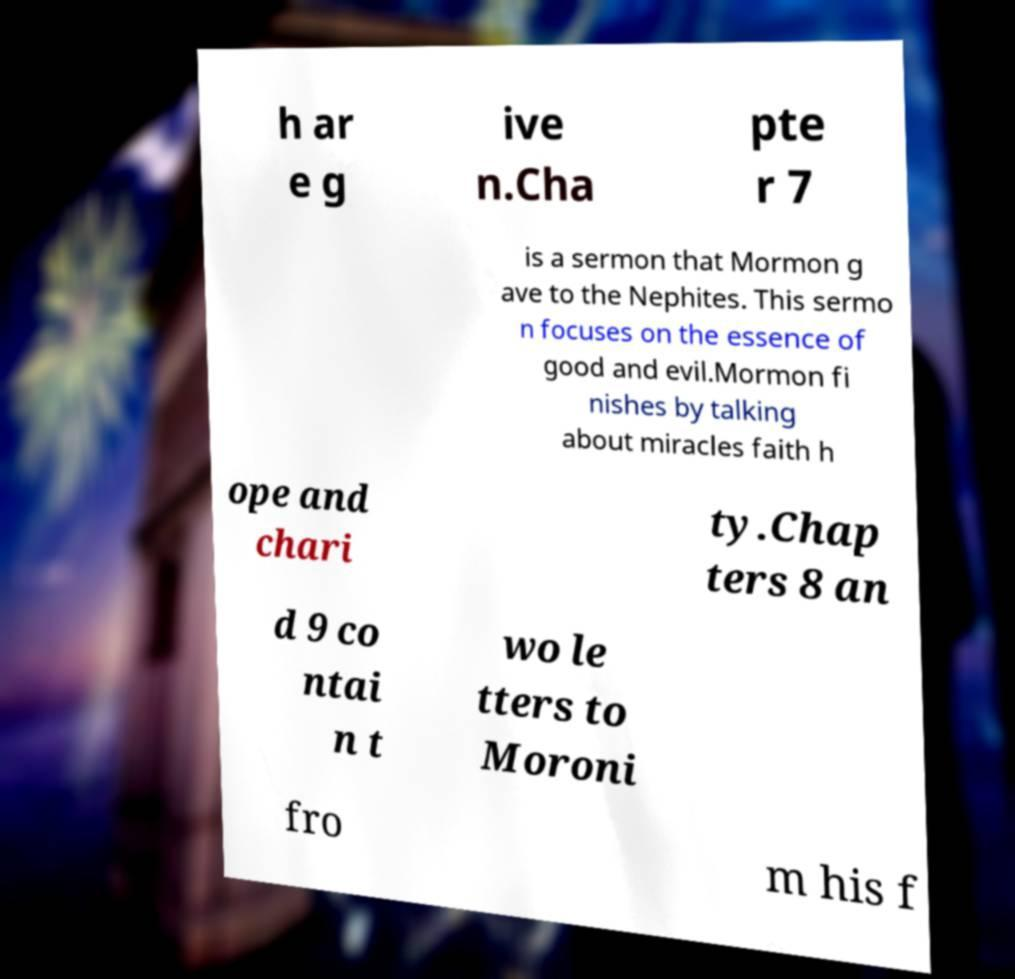Could you assist in decoding the text presented in this image and type it out clearly? h ar e g ive n.Cha pte r 7 is a sermon that Mormon g ave to the Nephites. This sermo n focuses on the essence of good and evil.Mormon fi nishes by talking about miracles faith h ope and chari ty.Chap ters 8 an d 9 co ntai n t wo le tters to Moroni fro m his f 